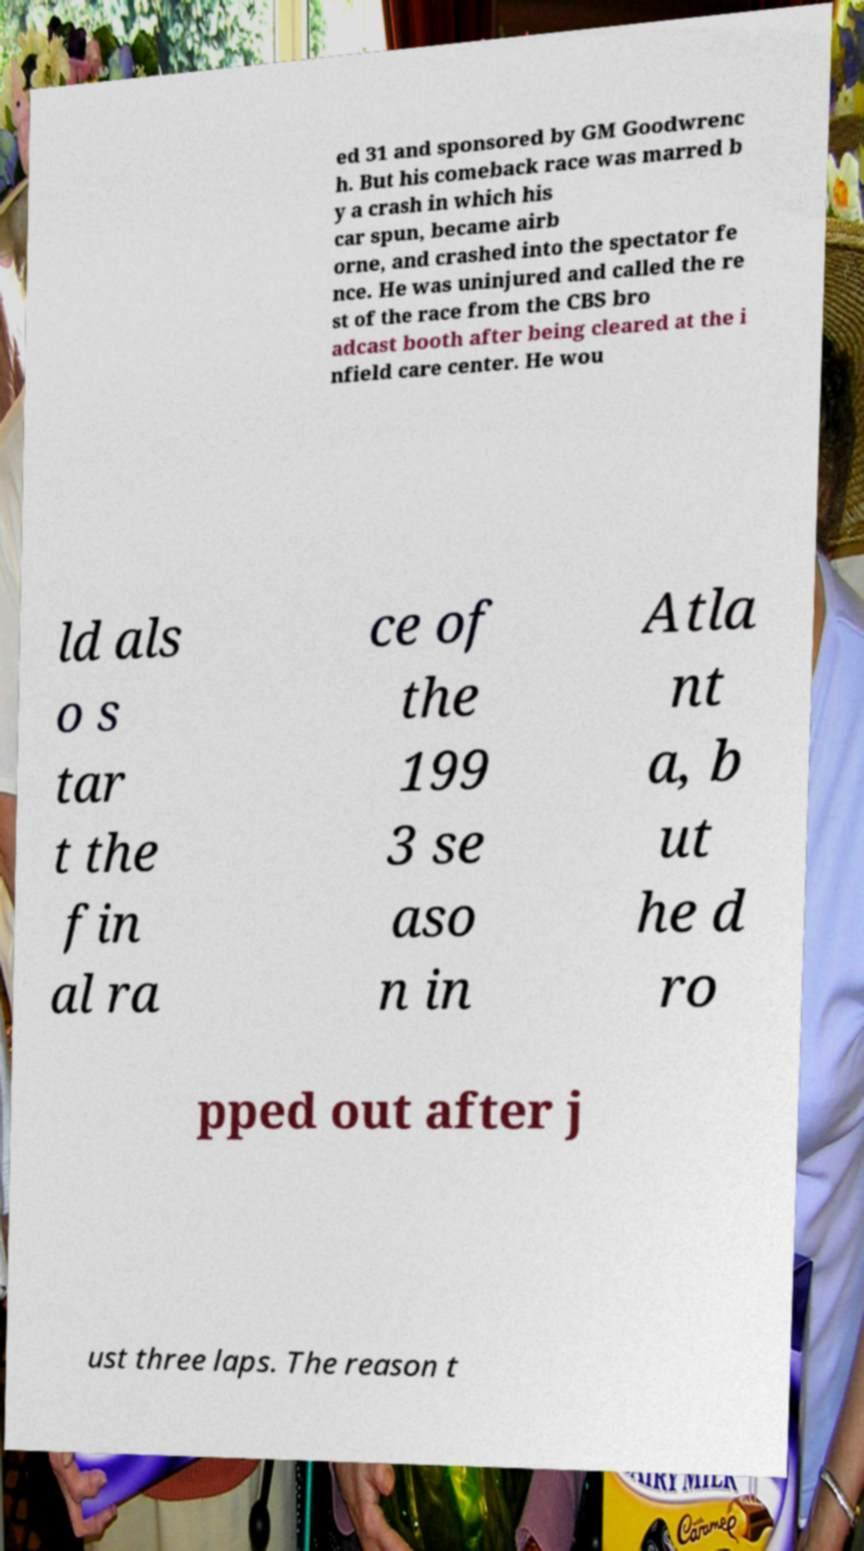Please identify and transcribe the text found in this image. ed 31 and sponsored by GM Goodwrenc h. But his comeback race was marred b y a crash in which his car spun, became airb orne, and crashed into the spectator fe nce. He was uninjured and called the re st of the race from the CBS bro adcast booth after being cleared at the i nfield care center. He wou ld als o s tar t the fin al ra ce of the 199 3 se aso n in Atla nt a, b ut he d ro pped out after j ust three laps. The reason t 